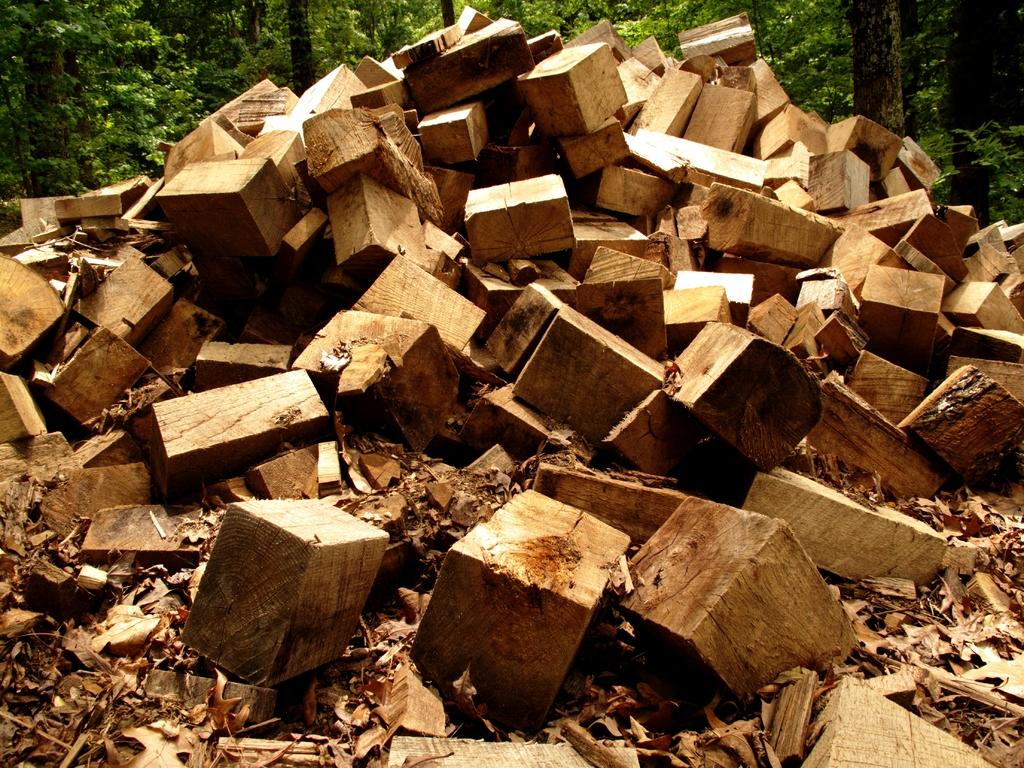What type of objects are in the foreground of the image? There are wooden logs in the foreground of the image. What can be seen in the background of the image? There are trees in the background of the image. What is the belief of the hole in the image? There is no hole present in the image, so it is not possible to discuss its beliefs. 